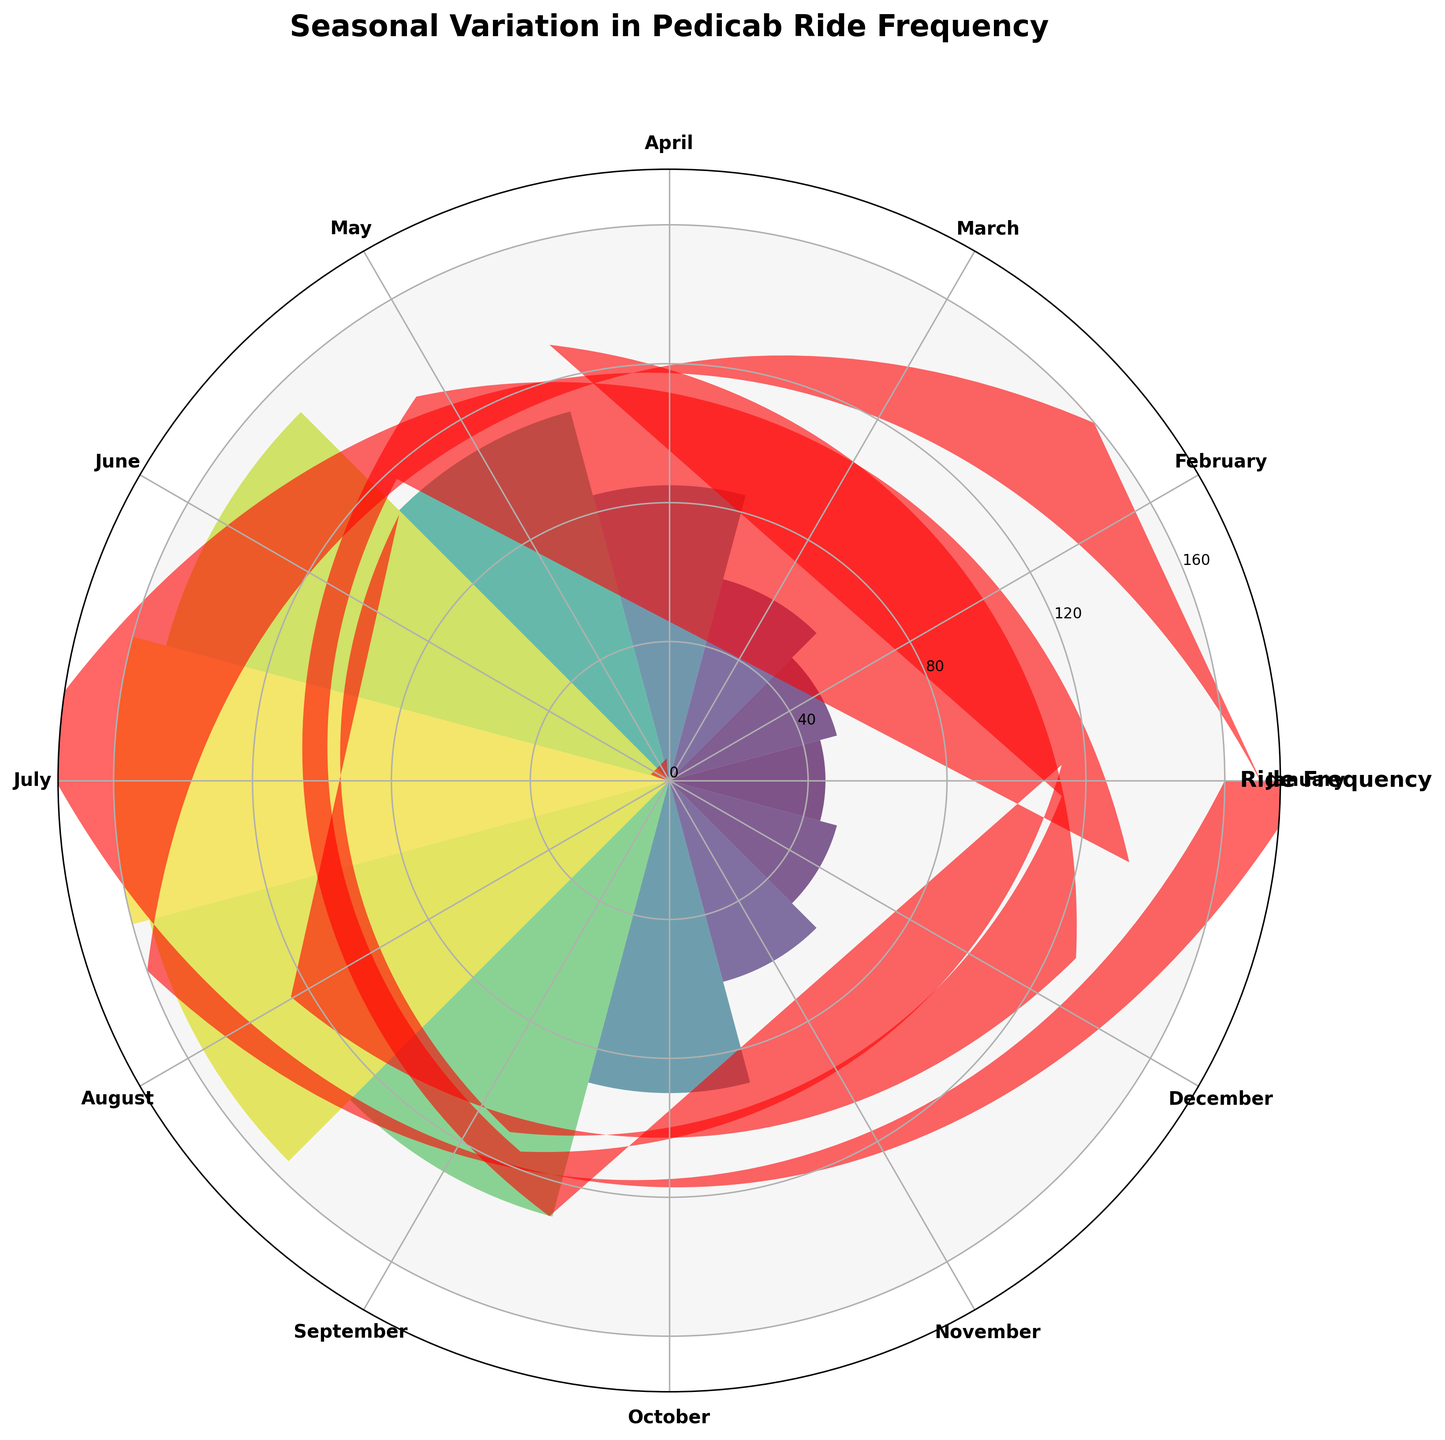Which month has the highest ride frequency? To find the month with the highest ride frequency, look at the length of the bars in the rose chart. The longest bar represents the month with the highest ride frequency.
Answer: July Which month has the lowest ride frequency? To determine the month with the lowest ride frequency, examine the shortest bar in the rose chart. The shortest bar indicates the month with the lowest ride frequency.
Answer: January What is the approximate ride frequency for April? Locate April on the rose chart and check the length of the bar corresponding to this month. The height of the bar is around 85.
Answer: 85 How does the ride frequency in July compare to January? Compare the bar lengths for July and January directly. The bar for July is much longer than the bar for January, indicating higher ride frequency in July.
Answer: July's frequency is much higher What is the average ride frequency for the months with the highest and lowest ride frequencies? Identify the highest ride frequency (July: 160) and the lowest (January: 45). Calculate the average: (160 + 45) / 2 = 102.5.
Answer: 102.5 During which month does ride frequency first exceed 100? Examine the bars sequentially from January onwards to find the first instance where the bar's length exceeds 100. This occurs in May.
Answer: May Which two consecutive months have the greatest difference in ride frequency? Check the length of the bars for consecutive months and compare the differences. The maximum difference is between April (85) and May (110), a difference of 25.
Answer: April and May What is the total ride frequency for the summer months (June, July, and August)? Sum the ride frequencies for June, July, and August: 150 + 160 + 155 = 465.
Answer: 465 How does the ride frequency in October compare to November? Compare the bar lengths for October and November. October's bar is approximately 90, and November's is around 60, showing that October's ride frequency is higher.
Answer: October's is higher Is there a noticeable seasonal pattern in ride frequency? Examine the distribution of bar lengths around the rose chart. Notably higher ride frequencies in summer months (June, July, and August) and lower in winter months suggest a seasonal pattern.
Answer: Yes, with higher in summer and lower in winter 